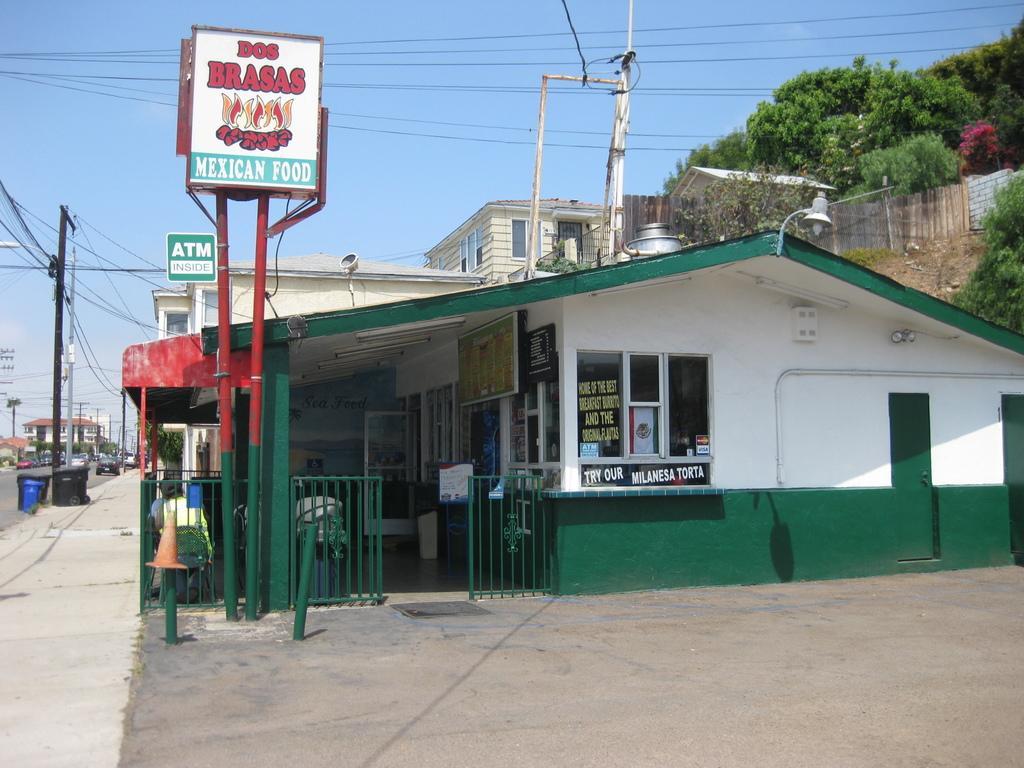Can you describe this image briefly? In the foreground of the picture we can see board, buildings, pole and road. On the left we can see current poles, cables, vehicles, dustbins, footpath, buildings and various objects. On the right there are trees, building and wall. At the top we can see cables and sky. 